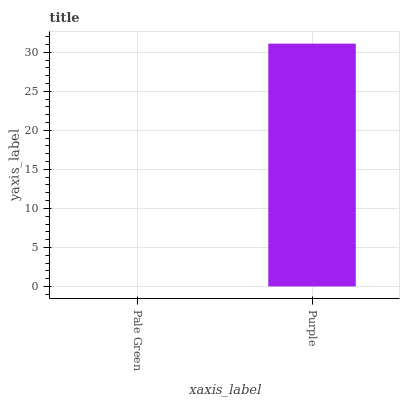Is Purple the minimum?
Answer yes or no. No. Is Purple greater than Pale Green?
Answer yes or no. Yes. Is Pale Green less than Purple?
Answer yes or no. Yes. Is Pale Green greater than Purple?
Answer yes or no. No. Is Purple less than Pale Green?
Answer yes or no. No. Is Purple the high median?
Answer yes or no. Yes. Is Pale Green the low median?
Answer yes or no. Yes. Is Pale Green the high median?
Answer yes or no. No. Is Purple the low median?
Answer yes or no. No. 